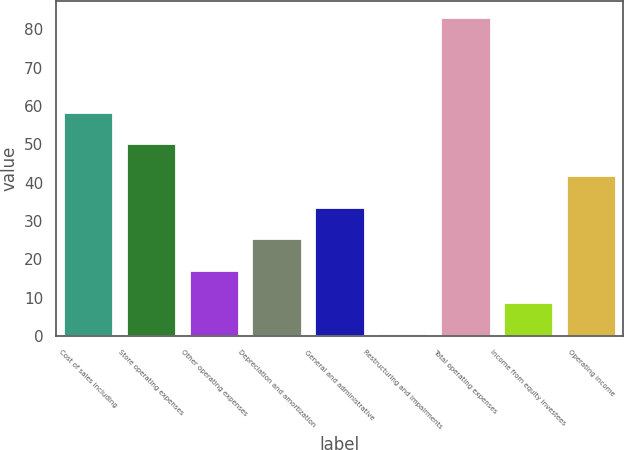Convert chart to OTSL. <chart><loc_0><loc_0><loc_500><loc_500><bar_chart><fcel>Cost of sales including<fcel>Store operating expenses<fcel>Other operating expenses<fcel>Depreciation and amortization<fcel>General and administrative<fcel>Restructuring and impairments<fcel>Total operating expenses<fcel>Income from equity investees<fcel>Operating income<nl><fcel>58.52<fcel>50.26<fcel>17.22<fcel>25.48<fcel>33.74<fcel>0.7<fcel>83.3<fcel>8.96<fcel>42<nl></chart> 